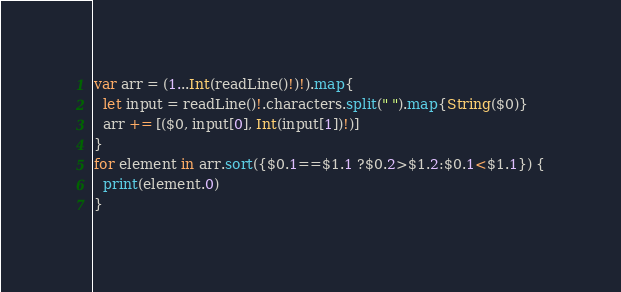Convert code to text. <code><loc_0><loc_0><loc_500><loc_500><_Swift_>var arr = (1...Int(readLine()!)!).map{
  let input = readLine()!.characters.split(" ").map{String($0)}
  arr += [($0, input[0], Int(input[1])!)]
}
for element in arr.sort({$0.1==$1.1 ?$0.2>$1.2:$0.1<$1.1}) {
  print(element.0)
}</code> 